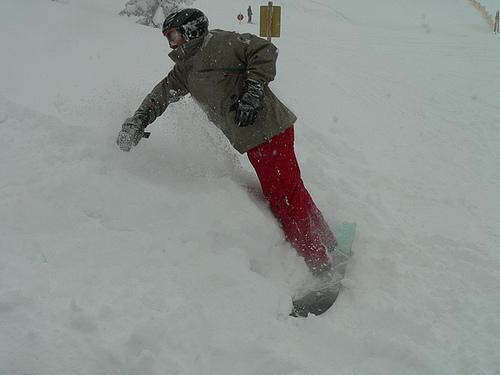Why is the person wearing a heavy jacket?

Choices:
A) as cosplay
B) fashion
C) for work
D) cold weather cold weather 